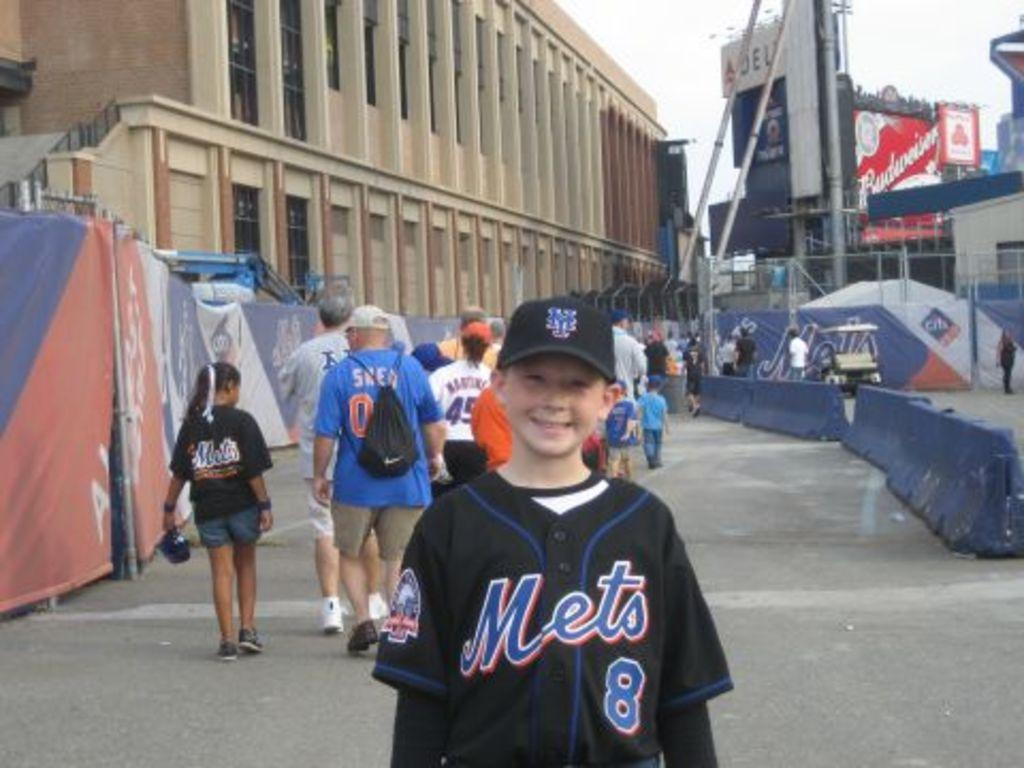Provide a one-sentence caption for the provided image. A young boy wearing a black Mets 8 jersey. 